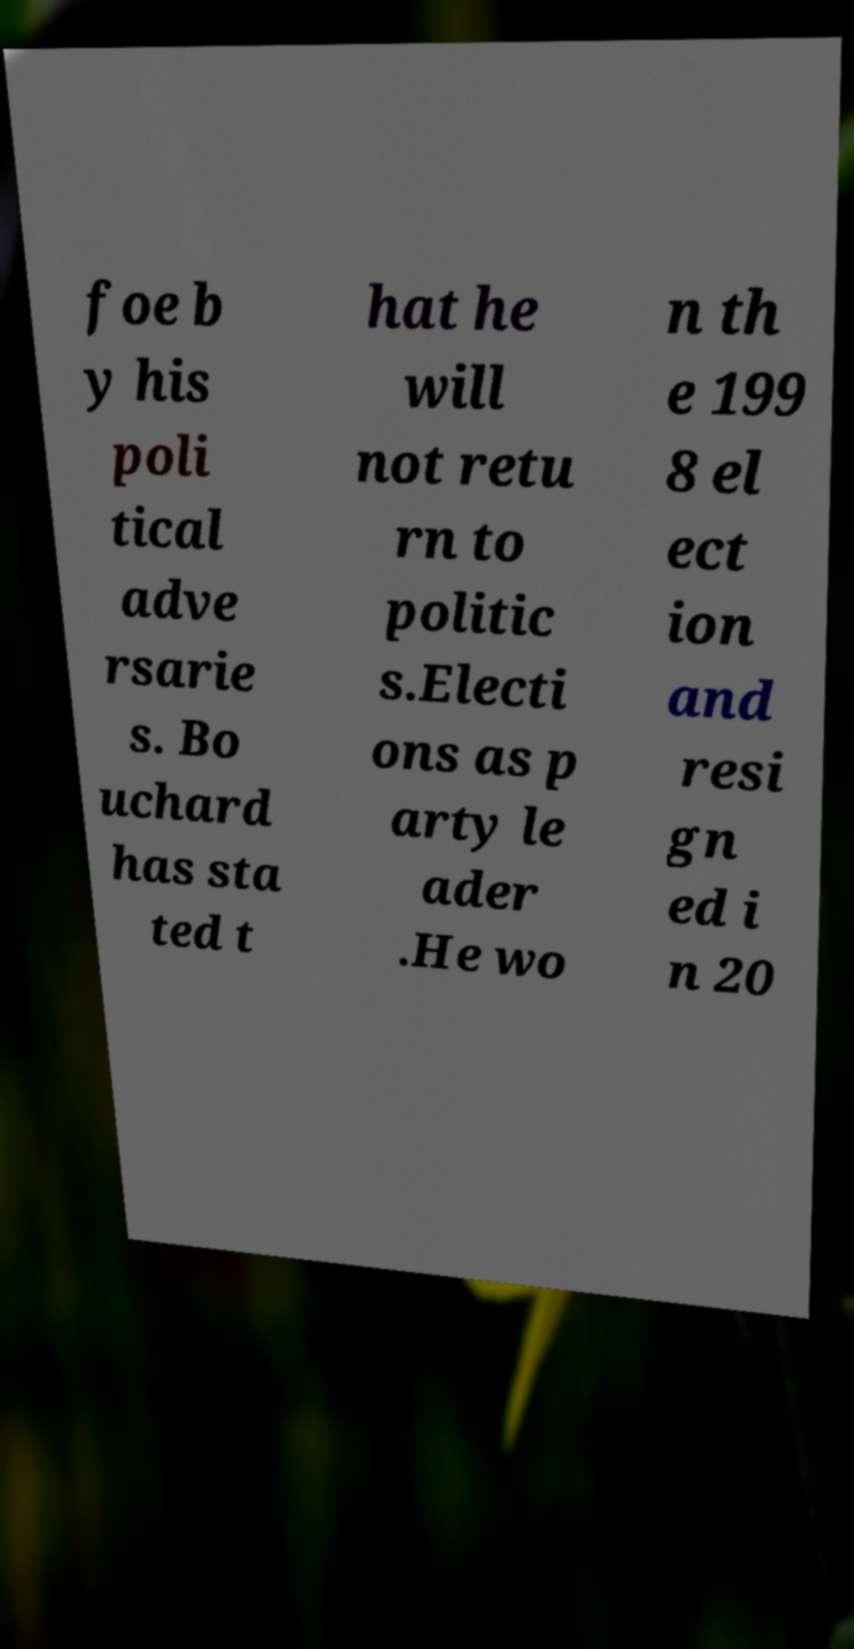Please read and relay the text visible in this image. What does it say? foe b y his poli tical adve rsarie s. Bo uchard has sta ted t hat he will not retu rn to politic s.Electi ons as p arty le ader .He wo n th e 199 8 el ect ion and resi gn ed i n 20 